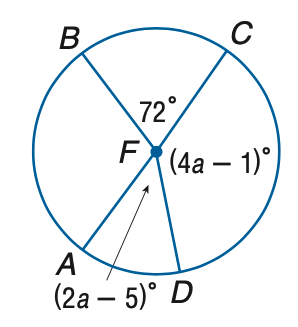Answer the mathemtical geometry problem and directly provide the correct option letter.
Question: Find the measure of \angle D F B on \odot F with diameter A C.
Choices: A: 163 B: 165 C: 167 D: 169 B 